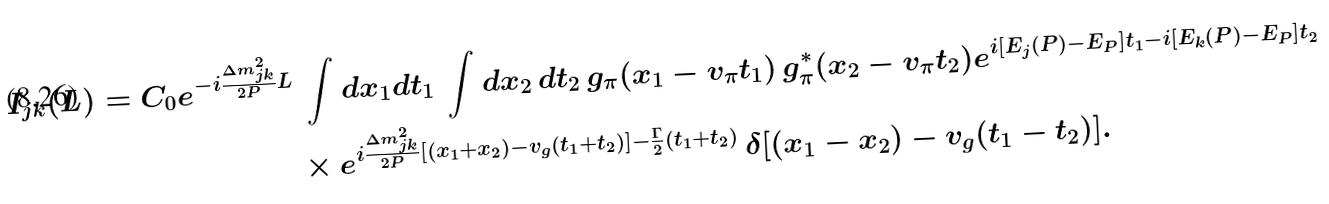<formula> <loc_0><loc_0><loc_500><loc_500>I _ { j k } ( L ) = C _ { 0 } e ^ { - i \frac { \Delta m _ { j k } ^ { 2 } } { 2 P } L } & \, \int d x _ { 1 } d t _ { 1 } \, \int d x _ { 2 } \, d t _ { 2 } \, g _ { \pi } ( x _ { 1 } - v _ { \pi } t _ { 1 } ) \, g ^ { * } _ { \pi } ( x _ { 2 } - v _ { \pi } t _ { 2 } ) e ^ { i [ E _ { j } ( P ) - E _ { P } ] t _ { 1 } - i [ E _ { k } ( P ) - E _ { P } ] t _ { 2 } } \\ & \times e ^ { i \frac { \Delta m _ { j k } ^ { 2 } } { 2 P } [ ( x _ { 1 } + x _ { 2 } ) - v _ { g } ( t _ { 1 } + t _ { 2 } ) ] - \frac { \Gamma } { 2 } ( t _ { 1 } + t _ { 2 } ) } \, \delta [ ( x _ { 1 } - x _ { 2 } ) - v _ { g } ( t _ { 1 } - t _ { 2 } ) ] .</formula> 